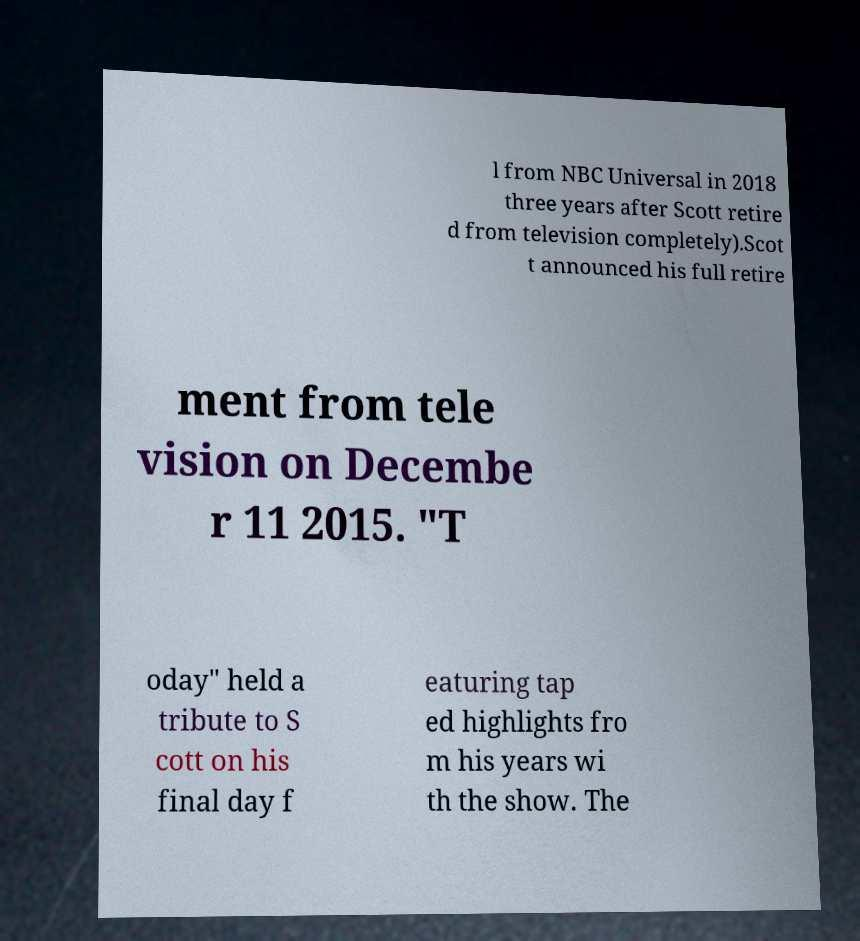Could you assist in decoding the text presented in this image and type it out clearly? l from NBC Universal in 2018 three years after Scott retire d from television completely).Scot t announced his full retire ment from tele vision on Decembe r 11 2015. "T oday" held a tribute to S cott on his final day f eaturing tap ed highlights fro m his years wi th the show. The 